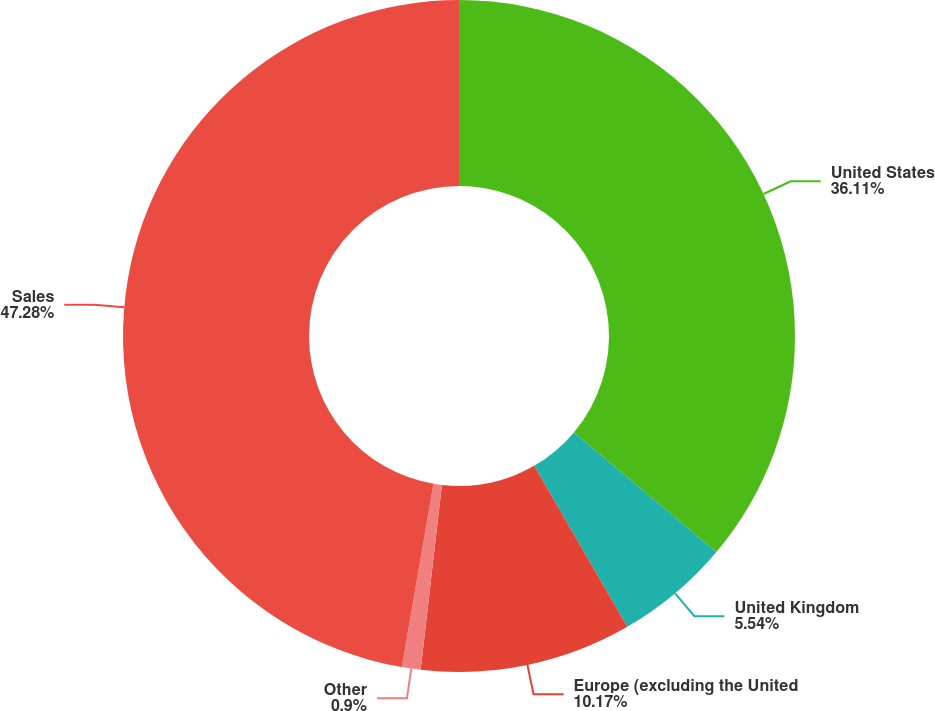Convert chart to OTSL. <chart><loc_0><loc_0><loc_500><loc_500><pie_chart><fcel>United States<fcel>United Kingdom<fcel>Europe (excluding the United<fcel>Other<fcel>Sales<nl><fcel>36.11%<fcel>5.54%<fcel>10.17%<fcel>0.9%<fcel>47.28%<nl></chart> 